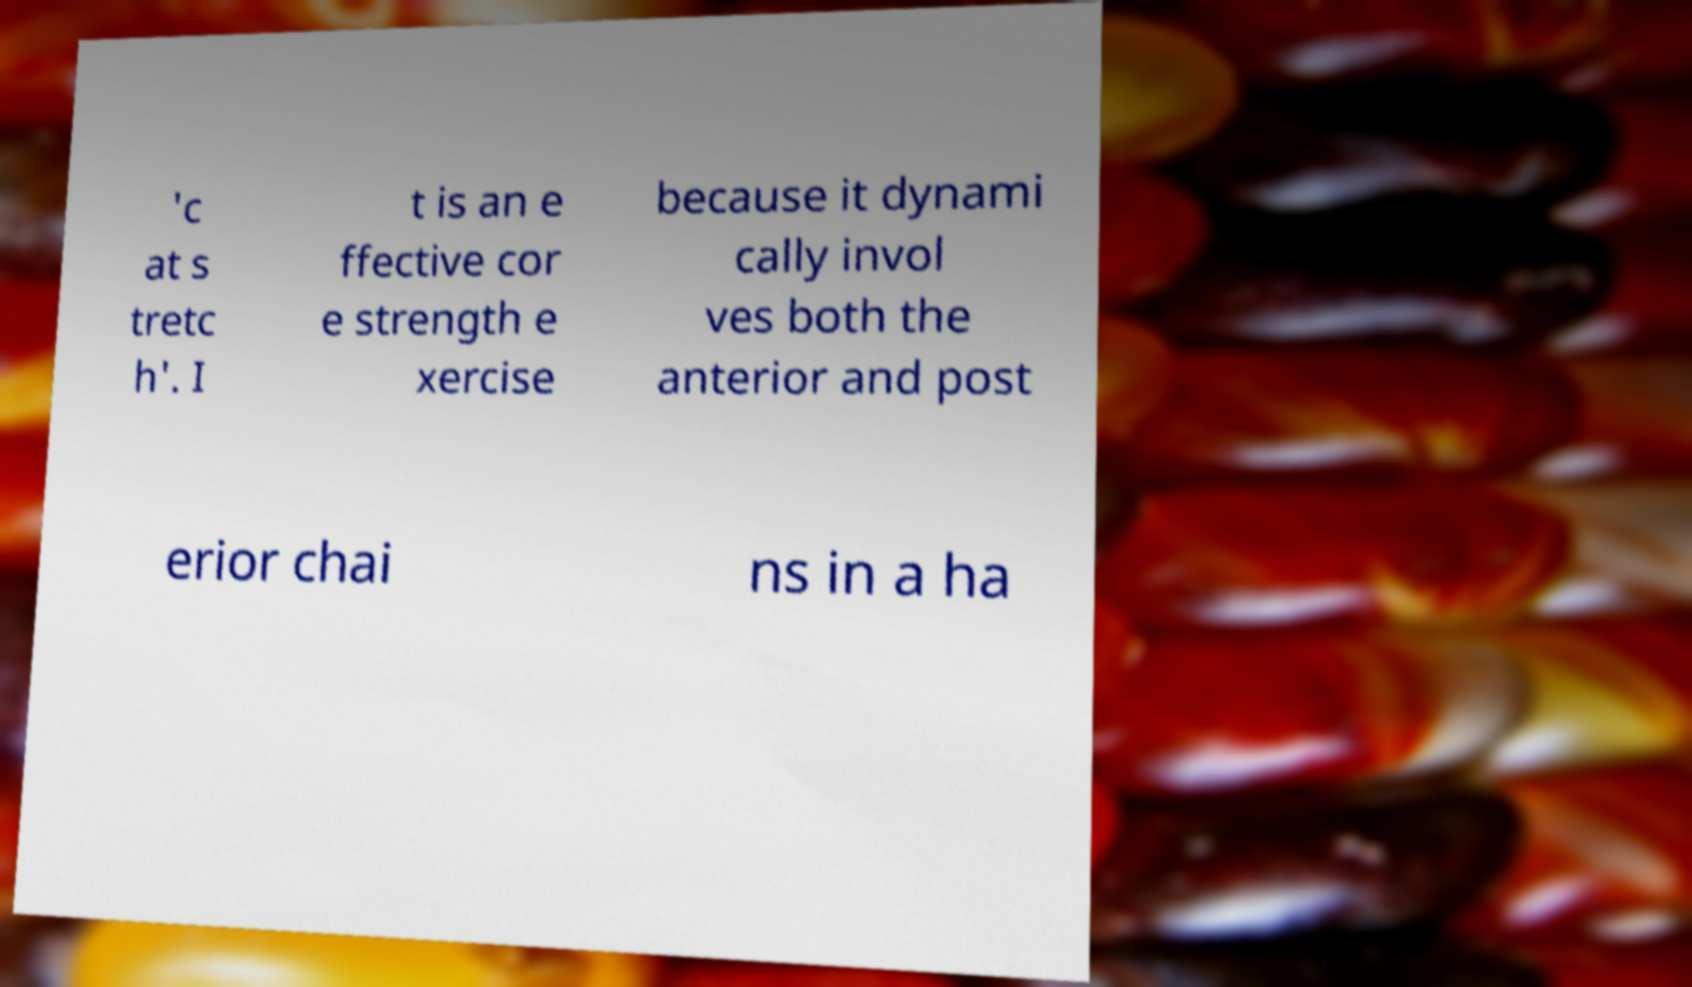There's text embedded in this image that I need extracted. Can you transcribe it verbatim? 'c at s tretc h'. I t is an e ffective cor e strength e xercise because it dynami cally invol ves both the anterior and post erior chai ns in a ha 